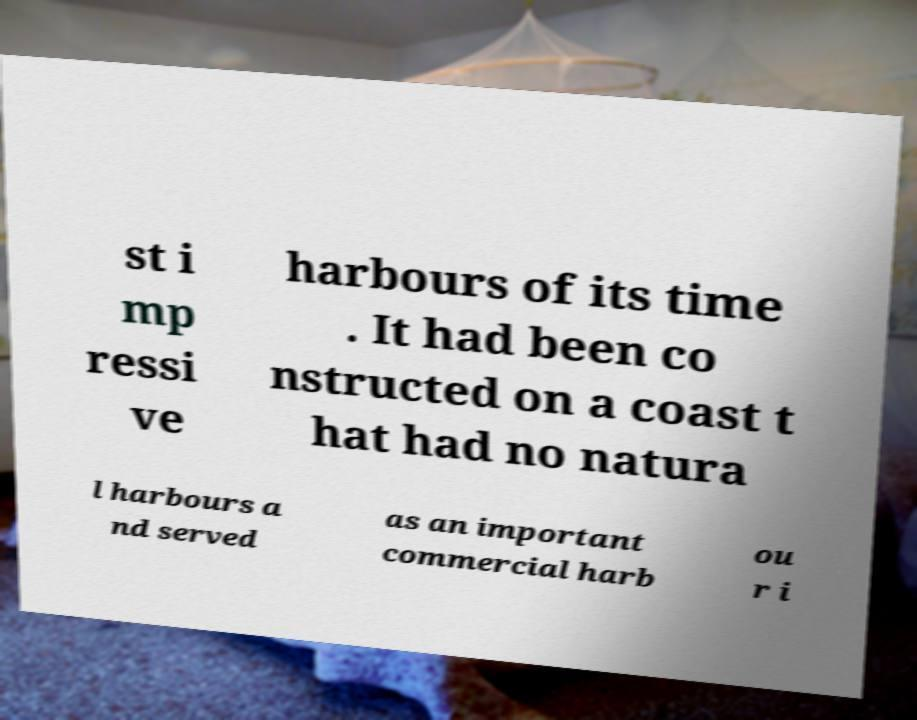Could you assist in decoding the text presented in this image and type it out clearly? st i mp ressi ve harbours of its time . It had been co nstructed on a coast t hat had no natura l harbours a nd served as an important commercial harb ou r i 